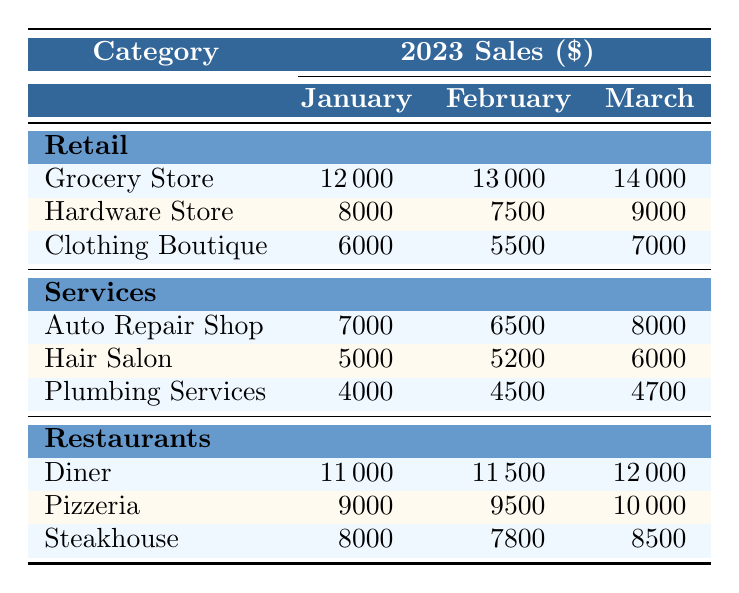What were the sales figures for the Grocery Store in March 2023? The table indicates that the Grocery Store had sales of 14,000 dollars in March 2023.
Answer: 14,000 Which month had the highest sales for the Diner? The table shows that the Diner had sales of 12,000 dollars in March 2023, which is higher than January's 11,000 and February's 11,500. Therefore, March had the highest sales for the Diner.
Answer: March What is the difference in sales between the Hardware Store and the Clothing Boutique in January 2023? In January 2023, the Hardware Store had sales of 8,000 dollars, while the Clothing Boutique had sales of 6,000 dollars. The difference between them is 8,000 - 6,000 = 2,000 dollars.
Answer: 2,000 Did the sales for Plumbing Services increase from January to March 2023? The table shows that Plumbing Services had sales of 4,000 dollars in January, 4,500 dollars in February, and 4,700 dollars in March. Since the sales figures increased over these months, the answer is yes.
Answer: Yes What is the total sales for all categories in February 2023? To find the total sales for February, add the sales of each business: Grocery Store (13,000) + Hardware Store (7,500) + Clothing Boutique (5,500) + Auto Repair Shop (6,500) + Hair Salon (5,200) + Plumbing Services (4,500) + Diner (11,500) + Pizzeria (9,500) + Steakhouse (7,800) = 70,000 dollars.
Answer: 70,000 What was the average sales figure for Restaurants over the first three months of 2023? The sales figures for Restaurants over the months are: Diner (11,000, 11,500, 12,000), Pizzeria (9,000, 9,500, 10,000), Steakhouse (8,000, 7,800, 8,500). First, sum each restaurant's sales: Diner total = 34,500, Pizzeria total = 28,500, Steakhouse total = 24,300. Then, total sales for all Restaurants = 34,500 + 28,500 + 24,300 = 87,300. Since we have three months, the average is 87,300 / 3 = 29,100 dollars.
Answer: 29,100 Was the total sales for Services greater than the total sales for Retail in January 2023? In January, total sales for Retail are 12,000 + 8,000 + 6,000 = 26,000 dollars, while total sales for Services are 7,000 + 5,000 + 4,000 = 16,000 dollars. Since 26,000 is greater than 16,000, the answer is yes.
Answer: Yes What is the sum of sales for all Clothing Boutiques for the first quarter of 2023? From January to March 2023, the sales figures for the Clothing Boutique are 6,000 (January) + 5,500 (February) + 7,000 (March). Adding these gives 6,000 + 5,500 + 7,000 = 18,500 dollars.
Answer: 18,500 